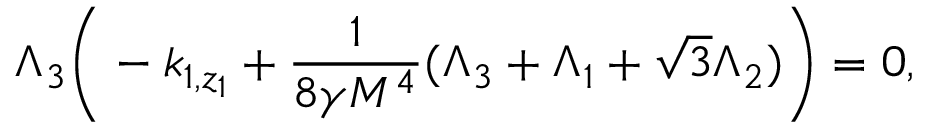Convert formula to latex. <formula><loc_0><loc_0><loc_500><loc_500>\Lambda _ { 3 } \left ( - k _ { 1 , z _ { 1 } } + \frac { 1 } { 8 \gamma M ^ { 4 } } ( \Lambda _ { 3 } + \Lambda _ { 1 } + \sqrt { 3 } \Lambda _ { 2 } ) \right ) = 0 ,</formula> 